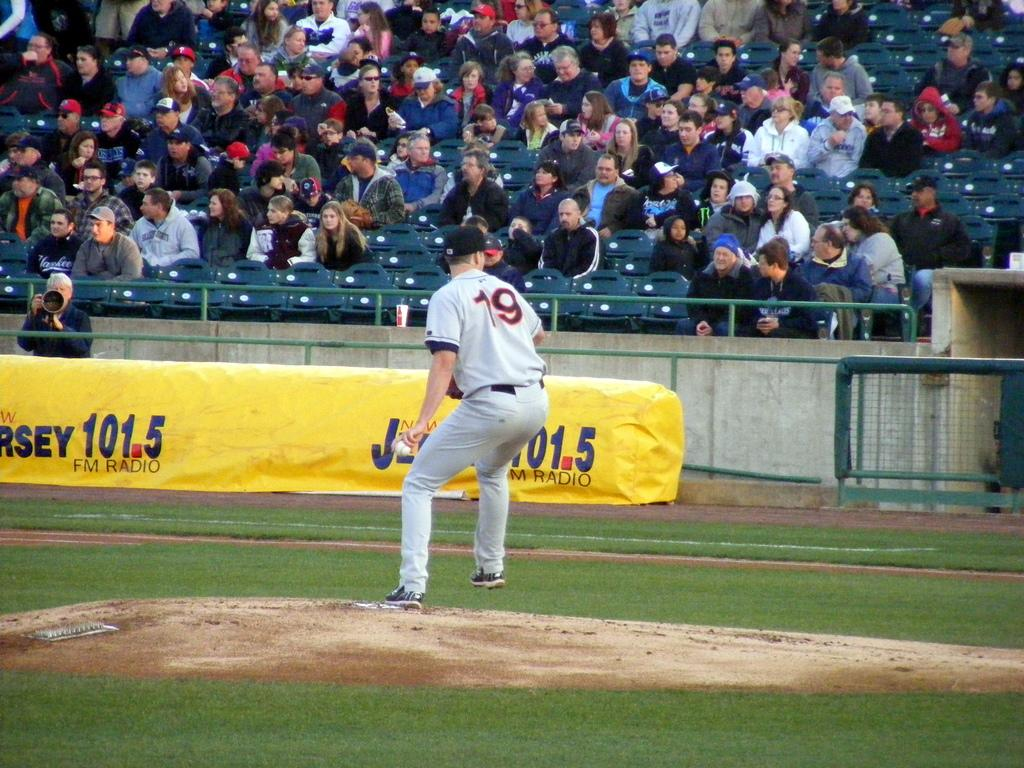Provide a one-sentence caption for the provided image. Player number 19 stands in front of an ad for radio station 101.5. 